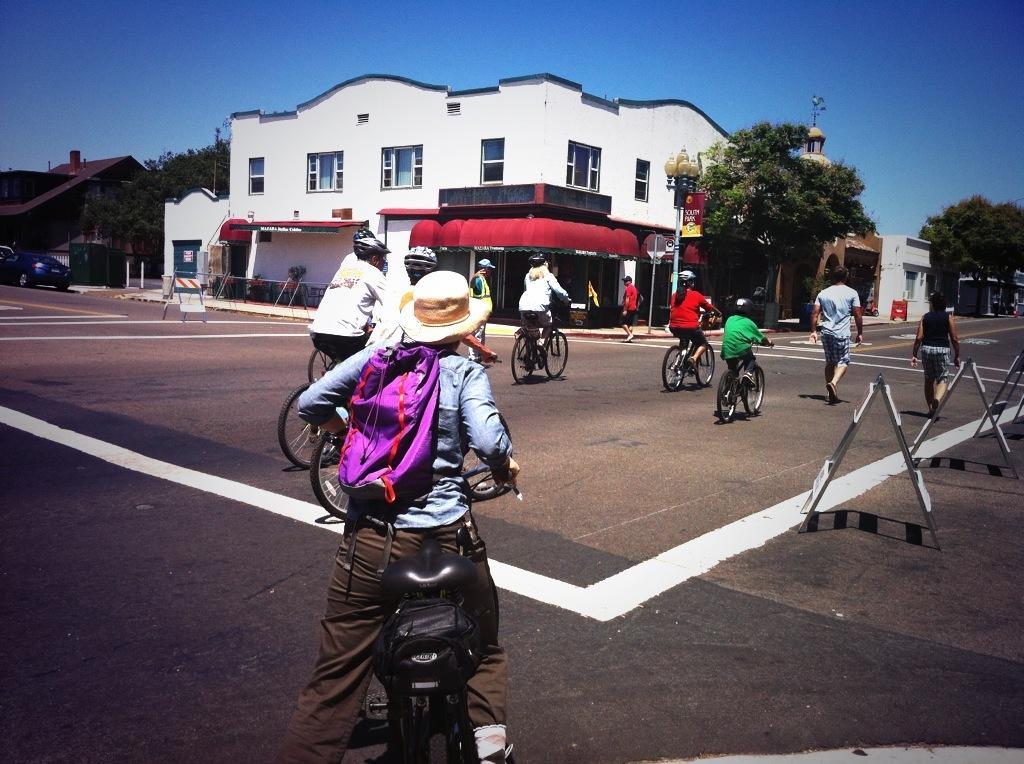Could you give a brief overview of what you see in this image? In this picture there are a group of people riding a bicycle on the road and in the backdrop there are trees, buildings, vehicles and the sky is clear 